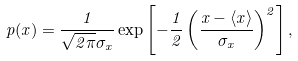<formula> <loc_0><loc_0><loc_500><loc_500>p ( x ) = \frac { 1 } { \sqrt { 2 \pi } \sigma _ { x } } \exp \left [ - \frac { 1 } { 2 } \left ( \frac { x - \langle x \rangle } { \sigma _ { x } } \right ) ^ { 2 } \right ] ,</formula> 